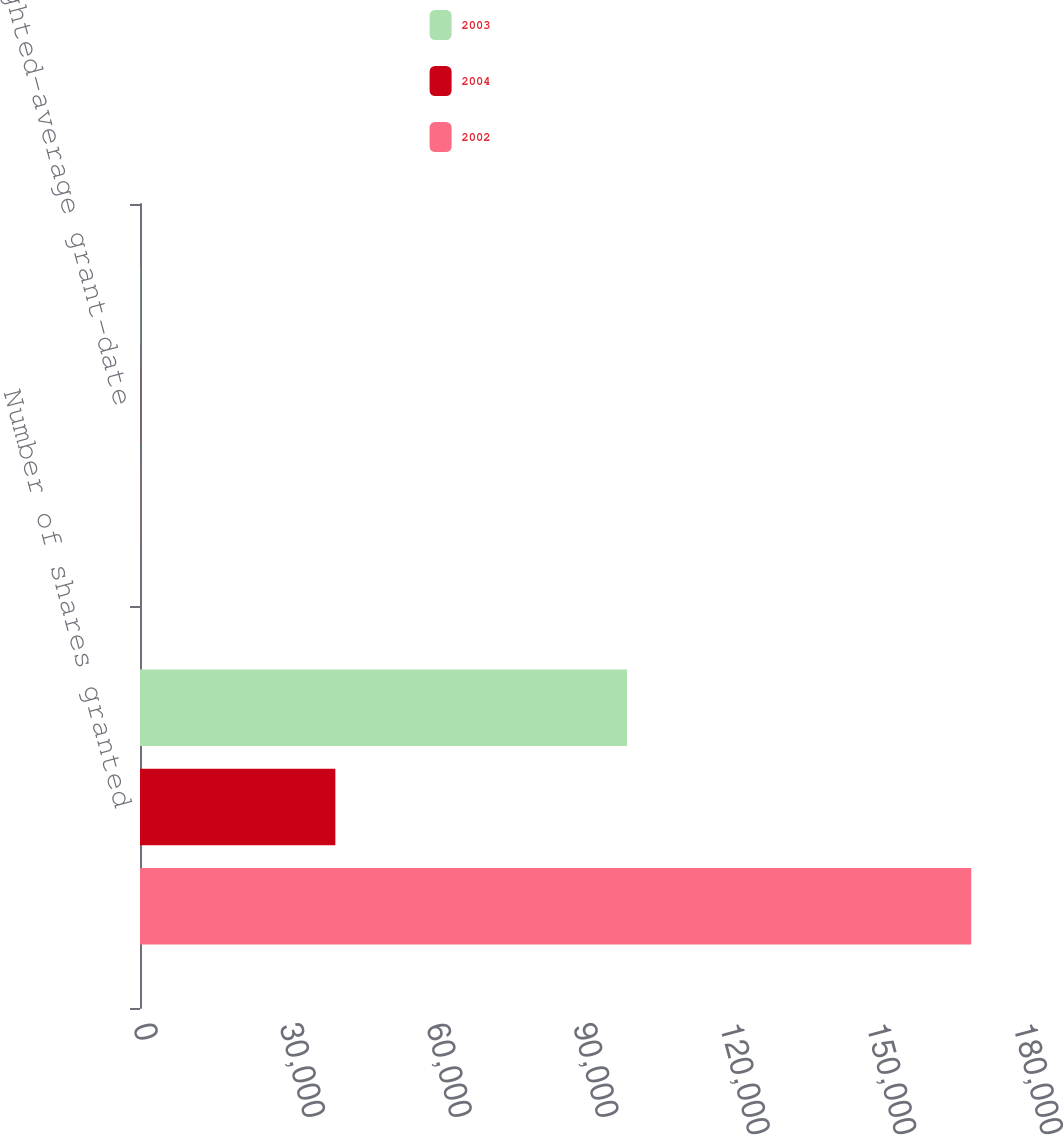Convert chart to OTSL. <chart><loc_0><loc_0><loc_500><loc_500><stacked_bar_chart><ecel><fcel>Number of shares granted<fcel>Weighted-average grant-date<nl><fcel>2003<fcel>99613<fcel>33.61<nl><fcel>2004<fcel>39960<fcel>25.52<nl><fcel>2002<fcel>170028<fcel>27.84<nl></chart> 